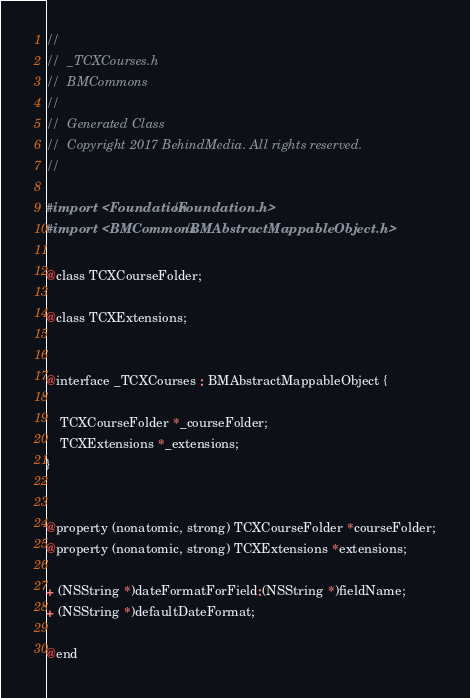Convert code to text. <code><loc_0><loc_0><loc_500><loc_500><_C_>//
//  _TCXCourses.h
//  BMCommons
//
//  Generated Class
//  Copyright 2017 BehindMedia. All rights reserved.
//

#import <Foundation/Foundation.h>
#import <BMCommons/BMAbstractMappableObject.h>

@class TCXCourseFolder;

@class TCXExtensions;


@interface _TCXCourses : BMAbstractMappableObject {
	
	TCXCourseFolder *_courseFolder;
	TCXExtensions *_extensions;
}


@property (nonatomic, strong) TCXCourseFolder *courseFolder;
@property (nonatomic, strong) TCXExtensions *extensions;

+ (NSString *)dateFormatForField:(NSString *)fieldName;
+ (NSString *)defaultDateFormat;

@end
</code> 